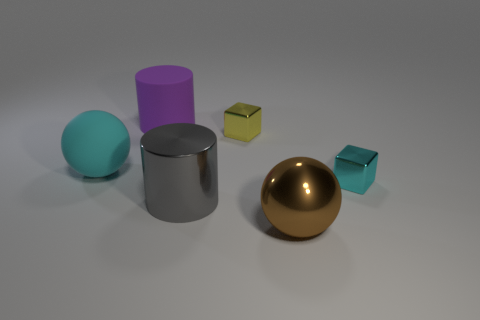Add 3 tiny yellow shiny cylinders. How many objects exist? 9 Subtract all cubes. How many objects are left? 4 Add 1 large purple cylinders. How many large purple cylinders exist? 2 Subtract 1 yellow blocks. How many objects are left? 5 Subtract all cubes. Subtract all tiny yellow matte cylinders. How many objects are left? 4 Add 4 small yellow metallic things. How many small yellow metallic things are left? 5 